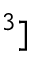Convert formula to latex. <formula><loc_0><loc_0><loc_500><loc_500>^ { 3 } ]</formula> 